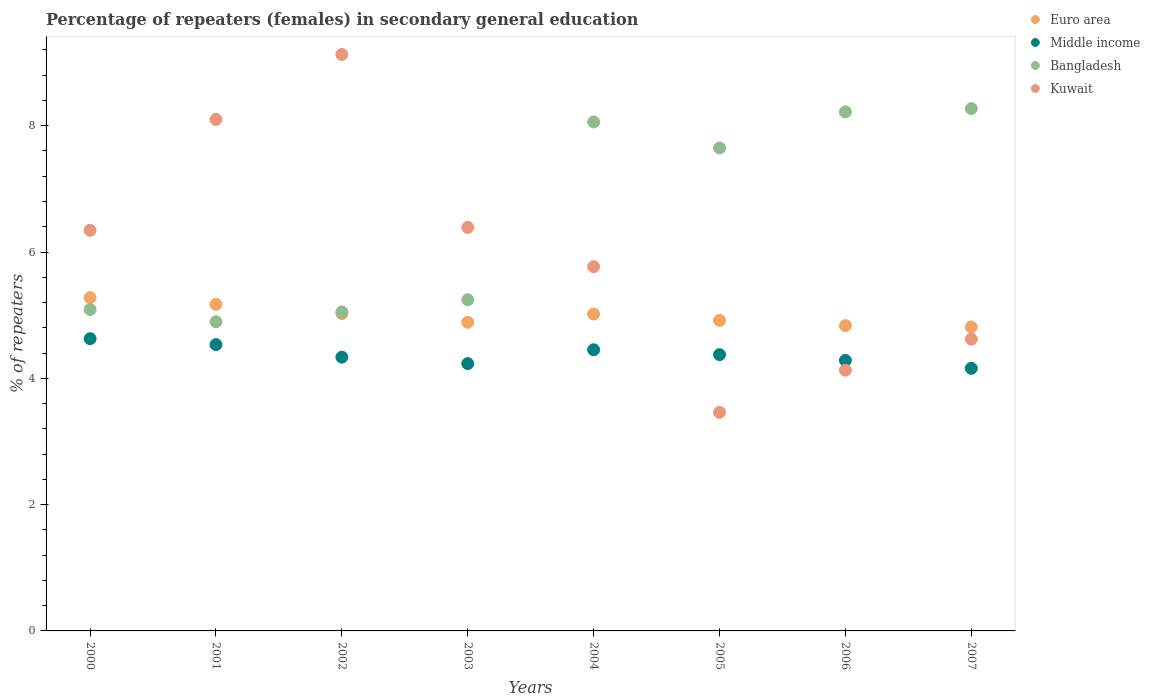What is the percentage of female repeaters in Euro area in 2002?
Give a very brief answer. 5.02. Across all years, what is the maximum percentage of female repeaters in Euro area?
Your answer should be very brief. 5.28. Across all years, what is the minimum percentage of female repeaters in Middle income?
Your answer should be compact. 4.16. In which year was the percentage of female repeaters in Kuwait maximum?
Keep it short and to the point. 2002. What is the total percentage of female repeaters in Kuwait in the graph?
Offer a terse response. 47.94. What is the difference between the percentage of female repeaters in Euro area in 2002 and that in 2007?
Provide a succinct answer. 0.21. What is the difference between the percentage of female repeaters in Kuwait in 2006 and the percentage of female repeaters in Bangladesh in 2001?
Offer a very short reply. -0.77. What is the average percentage of female repeaters in Kuwait per year?
Offer a very short reply. 5.99. In the year 2003, what is the difference between the percentage of female repeaters in Euro area and percentage of female repeaters in Kuwait?
Offer a very short reply. -1.5. What is the ratio of the percentage of female repeaters in Kuwait in 2001 to that in 2004?
Your answer should be very brief. 1.4. Is the difference between the percentage of female repeaters in Euro area in 2001 and 2003 greater than the difference between the percentage of female repeaters in Kuwait in 2001 and 2003?
Your response must be concise. No. What is the difference between the highest and the second highest percentage of female repeaters in Bangladesh?
Your response must be concise. 0.05. What is the difference between the highest and the lowest percentage of female repeaters in Bangladesh?
Offer a very short reply. 3.38. Is the sum of the percentage of female repeaters in Middle income in 2005 and 2007 greater than the maximum percentage of female repeaters in Bangladesh across all years?
Keep it short and to the point. Yes. Is it the case that in every year, the sum of the percentage of female repeaters in Euro area and percentage of female repeaters in Kuwait  is greater than the percentage of female repeaters in Middle income?
Give a very brief answer. Yes. Does the percentage of female repeaters in Kuwait monotonically increase over the years?
Keep it short and to the point. No. Is the percentage of female repeaters in Bangladesh strictly greater than the percentage of female repeaters in Kuwait over the years?
Make the answer very short. No. Is the percentage of female repeaters in Middle income strictly less than the percentage of female repeaters in Euro area over the years?
Keep it short and to the point. Yes. Are the values on the major ticks of Y-axis written in scientific E-notation?
Provide a short and direct response. No. How many legend labels are there?
Keep it short and to the point. 4. How are the legend labels stacked?
Keep it short and to the point. Vertical. What is the title of the graph?
Provide a short and direct response. Percentage of repeaters (females) in secondary general education. What is the label or title of the X-axis?
Your response must be concise. Years. What is the label or title of the Y-axis?
Ensure brevity in your answer.  % of repeaters. What is the % of repeaters in Euro area in 2000?
Make the answer very short. 5.28. What is the % of repeaters of Middle income in 2000?
Offer a terse response. 4.63. What is the % of repeaters in Bangladesh in 2000?
Offer a terse response. 5.09. What is the % of repeaters of Kuwait in 2000?
Keep it short and to the point. 6.34. What is the % of repeaters in Euro area in 2001?
Make the answer very short. 5.17. What is the % of repeaters in Middle income in 2001?
Your answer should be compact. 4.53. What is the % of repeaters in Bangladesh in 2001?
Ensure brevity in your answer.  4.9. What is the % of repeaters of Kuwait in 2001?
Your answer should be compact. 8.1. What is the % of repeaters of Euro area in 2002?
Give a very brief answer. 5.02. What is the % of repeaters in Middle income in 2002?
Keep it short and to the point. 4.34. What is the % of repeaters in Bangladesh in 2002?
Provide a succinct answer. 5.05. What is the % of repeaters of Kuwait in 2002?
Provide a short and direct response. 9.13. What is the % of repeaters of Euro area in 2003?
Your answer should be very brief. 4.89. What is the % of repeaters in Middle income in 2003?
Keep it short and to the point. 4.23. What is the % of repeaters in Bangladesh in 2003?
Your response must be concise. 5.24. What is the % of repeaters of Kuwait in 2003?
Keep it short and to the point. 6.39. What is the % of repeaters in Euro area in 2004?
Offer a very short reply. 5.02. What is the % of repeaters in Middle income in 2004?
Your answer should be very brief. 4.45. What is the % of repeaters in Bangladesh in 2004?
Your response must be concise. 8.06. What is the % of repeaters of Kuwait in 2004?
Ensure brevity in your answer.  5.77. What is the % of repeaters of Euro area in 2005?
Your answer should be compact. 4.92. What is the % of repeaters of Middle income in 2005?
Make the answer very short. 4.38. What is the % of repeaters in Bangladesh in 2005?
Your answer should be very brief. 7.65. What is the % of repeaters in Kuwait in 2005?
Provide a short and direct response. 3.46. What is the % of repeaters of Euro area in 2006?
Your answer should be compact. 4.83. What is the % of repeaters of Middle income in 2006?
Make the answer very short. 4.28. What is the % of repeaters of Bangladesh in 2006?
Offer a terse response. 8.22. What is the % of repeaters of Kuwait in 2006?
Your answer should be very brief. 4.13. What is the % of repeaters of Euro area in 2007?
Ensure brevity in your answer.  4.81. What is the % of repeaters of Middle income in 2007?
Ensure brevity in your answer.  4.16. What is the % of repeaters in Bangladesh in 2007?
Make the answer very short. 8.27. What is the % of repeaters of Kuwait in 2007?
Provide a succinct answer. 4.62. Across all years, what is the maximum % of repeaters in Euro area?
Your answer should be compact. 5.28. Across all years, what is the maximum % of repeaters in Middle income?
Make the answer very short. 4.63. Across all years, what is the maximum % of repeaters of Bangladesh?
Give a very brief answer. 8.27. Across all years, what is the maximum % of repeaters in Kuwait?
Provide a succinct answer. 9.13. Across all years, what is the minimum % of repeaters in Euro area?
Make the answer very short. 4.81. Across all years, what is the minimum % of repeaters in Middle income?
Make the answer very short. 4.16. Across all years, what is the minimum % of repeaters of Bangladesh?
Give a very brief answer. 4.9. Across all years, what is the minimum % of repeaters of Kuwait?
Ensure brevity in your answer.  3.46. What is the total % of repeaters of Euro area in the graph?
Your answer should be very brief. 39.94. What is the total % of repeaters in Middle income in the graph?
Offer a very short reply. 35. What is the total % of repeaters of Bangladesh in the graph?
Your answer should be compact. 52.48. What is the total % of repeaters in Kuwait in the graph?
Offer a terse response. 47.94. What is the difference between the % of repeaters in Euro area in 2000 and that in 2001?
Give a very brief answer. 0.11. What is the difference between the % of repeaters in Middle income in 2000 and that in 2001?
Ensure brevity in your answer.  0.09. What is the difference between the % of repeaters of Bangladesh in 2000 and that in 2001?
Give a very brief answer. 0.19. What is the difference between the % of repeaters in Kuwait in 2000 and that in 2001?
Your answer should be compact. -1.76. What is the difference between the % of repeaters of Euro area in 2000 and that in 2002?
Your answer should be very brief. 0.25. What is the difference between the % of repeaters in Middle income in 2000 and that in 2002?
Offer a very short reply. 0.29. What is the difference between the % of repeaters of Bangladesh in 2000 and that in 2002?
Your answer should be compact. 0.04. What is the difference between the % of repeaters in Kuwait in 2000 and that in 2002?
Your answer should be very brief. -2.78. What is the difference between the % of repeaters of Euro area in 2000 and that in 2003?
Ensure brevity in your answer.  0.39. What is the difference between the % of repeaters of Middle income in 2000 and that in 2003?
Your answer should be compact. 0.39. What is the difference between the % of repeaters in Bangladesh in 2000 and that in 2003?
Keep it short and to the point. -0.15. What is the difference between the % of repeaters in Kuwait in 2000 and that in 2003?
Your answer should be compact. -0.05. What is the difference between the % of repeaters of Euro area in 2000 and that in 2004?
Keep it short and to the point. 0.26. What is the difference between the % of repeaters of Middle income in 2000 and that in 2004?
Your response must be concise. 0.18. What is the difference between the % of repeaters in Bangladesh in 2000 and that in 2004?
Give a very brief answer. -2.97. What is the difference between the % of repeaters in Kuwait in 2000 and that in 2004?
Offer a terse response. 0.58. What is the difference between the % of repeaters of Euro area in 2000 and that in 2005?
Your answer should be compact. 0.36. What is the difference between the % of repeaters in Middle income in 2000 and that in 2005?
Your answer should be compact. 0.25. What is the difference between the % of repeaters of Bangladesh in 2000 and that in 2005?
Make the answer very short. -2.56. What is the difference between the % of repeaters in Kuwait in 2000 and that in 2005?
Give a very brief answer. 2.88. What is the difference between the % of repeaters in Euro area in 2000 and that in 2006?
Offer a very short reply. 0.44. What is the difference between the % of repeaters in Middle income in 2000 and that in 2006?
Your answer should be very brief. 0.34. What is the difference between the % of repeaters in Bangladesh in 2000 and that in 2006?
Give a very brief answer. -3.13. What is the difference between the % of repeaters in Kuwait in 2000 and that in 2006?
Provide a short and direct response. 2.22. What is the difference between the % of repeaters of Euro area in 2000 and that in 2007?
Offer a terse response. 0.46. What is the difference between the % of repeaters in Middle income in 2000 and that in 2007?
Provide a short and direct response. 0.47. What is the difference between the % of repeaters in Bangladesh in 2000 and that in 2007?
Make the answer very short. -3.18. What is the difference between the % of repeaters of Kuwait in 2000 and that in 2007?
Ensure brevity in your answer.  1.72. What is the difference between the % of repeaters in Euro area in 2001 and that in 2002?
Provide a succinct answer. 0.15. What is the difference between the % of repeaters in Middle income in 2001 and that in 2002?
Your response must be concise. 0.2. What is the difference between the % of repeaters of Bangladesh in 2001 and that in 2002?
Your answer should be compact. -0.16. What is the difference between the % of repeaters in Kuwait in 2001 and that in 2002?
Your answer should be compact. -1.03. What is the difference between the % of repeaters in Euro area in 2001 and that in 2003?
Ensure brevity in your answer.  0.28. What is the difference between the % of repeaters in Middle income in 2001 and that in 2003?
Keep it short and to the point. 0.3. What is the difference between the % of repeaters in Bangladesh in 2001 and that in 2003?
Make the answer very short. -0.35. What is the difference between the % of repeaters in Kuwait in 2001 and that in 2003?
Provide a short and direct response. 1.71. What is the difference between the % of repeaters of Euro area in 2001 and that in 2004?
Offer a terse response. 0.15. What is the difference between the % of repeaters of Middle income in 2001 and that in 2004?
Your response must be concise. 0.08. What is the difference between the % of repeaters in Bangladesh in 2001 and that in 2004?
Keep it short and to the point. -3.16. What is the difference between the % of repeaters of Kuwait in 2001 and that in 2004?
Give a very brief answer. 2.33. What is the difference between the % of repeaters of Euro area in 2001 and that in 2005?
Provide a short and direct response. 0.26. What is the difference between the % of repeaters of Middle income in 2001 and that in 2005?
Provide a succinct answer. 0.16. What is the difference between the % of repeaters in Bangladesh in 2001 and that in 2005?
Your answer should be compact. -2.75. What is the difference between the % of repeaters in Kuwait in 2001 and that in 2005?
Provide a succinct answer. 4.64. What is the difference between the % of repeaters in Euro area in 2001 and that in 2006?
Ensure brevity in your answer.  0.34. What is the difference between the % of repeaters of Middle income in 2001 and that in 2006?
Keep it short and to the point. 0.25. What is the difference between the % of repeaters of Bangladesh in 2001 and that in 2006?
Make the answer very short. -3.32. What is the difference between the % of repeaters in Kuwait in 2001 and that in 2006?
Provide a short and direct response. 3.97. What is the difference between the % of repeaters in Euro area in 2001 and that in 2007?
Your answer should be compact. 0.36. What is the difference between the % of repeaters in Middle income in 2001 and that in 2007?
Offer a very short reply. 0.38. What is the difference between the % of repeaters in Bangladesh in 2001 and that in 2007?
Offer a very short reply. -3.38. What is the difference between the % of repeaters of Kuwait in 2001 and that in 2007?
Offer a very short reply. 3.48. What is the difference between the % of repeaters of Euro area in 2002 and that in 2003?
Your answer should be very brief. 0.14. What is the difference between the % of repeaters in Middle income in 2002 and that in 2003?
Ensure brevity in your answer.  0.1. What is the difference between the % of repeaters in Bangladesh in 2002 and that in 2003?
Your answer should be very brief. -0.19. What is the difference between the % of repeaters in Kuwait in 2002 and that in 2003?
Give a very brief answer. 2.74. What is the difference between the % of repeaters in Euro area in 2002 and that in 2004?
Ensure brevity in your answer.  0.01. What is the difference between the % of repeaters of Middle income in 2002 and that in 2004?
Offer a terse response. -0.12. What is the difference between the % of repeaters of Bangladesh in 2002 and that in 2004?
Make the answer very short. -3.01. What is the difference between the % of repeaters of Kuwait in 2002 and that in 2004?
Your answer should be very brief. 3.36. What is the difference between the % of repeaters of Euro area in 2002 and that in 2005?
Your answer should be compact. 0.11. What is the difference between the % of repeaters in Middle income in 2002 and that in 2005?
Keep it short and to the point. -0.04. What is the difference between the % of repeaters of Bangladesh in 2002 and that in 2005?
Your response must be concise. -2.6. What is the difference between the % of repeaters in Kuwait in 2002 and that in 2005?
Provide a succinct answer. 5.67. What is the difference between the % of repeaters of Euro area in 2002 and that in 2006?
Offer a terse response. 0.19. What is the difference between the % of repeaters of Middle income in 2002 and that in 2006?
Ensure brevity in your answer.  0.05. What is the difference between the % of repeaters in Bangladesh in 2002 and that in 2006?
Your response must be concise. -3.17. What is the difference between the % of repeaters in Kuwait in 2002 and that in 2006?
Offer a terse response. 5. What is the difference between the % of repeaters in Euro area in 2002 and that in 2007?
Give a very brief answer. 0.21. What is the difference between the % of repeaters in Middle income in 2002 and that in 2007?
Offer a very short reply. 0.18. What is the difference between the % of repeaters in Bangladesh in 2002 and that in 2007?
Ensure brevity in your answer.  -3.22. What is the difference between the % of repeaters in Kuwait in 2002 and that in 2007?
Ensure brevity in your answer.  4.51. What is the difference between the % of repeaters in Euro area in 2003 and that in 2004?
Give a very brief answer. -0.13. What is the difference between the % of repeaters of Middle income in 2003 and that in 2004?
Provide a succinct answer. -0.22. What is the difference between the % of repeaters of Bangladesh in 2003 and that in 2004?
Your answer should be compact. -2.82. What is the difference between the % of repeaters in Kuwait in 2003 and that in 2004?
Your answer should be compact. 0.62. What is the difference between the % of repeaters in Euro area in 2003 and that in 2005?
Offer a terse response. -0.03. What is the difference between the % of repeaters in Middle income in 2003 and that in 2005?
Make the answer very short. -0.14. What is the difference between the % of repeaters in Bangladesh in 2003 and that in 2005?
Ensure brevity in your answer.  -2.4. What is the difference between the % of repeaters in Kuwait in 2003 and that in 2005?
Provide a succinct answer. 2.93. What is the difference between the % of repeaters in Euro area in 2003 and that in 2006?
Give a very brief answer. 0.05. What is the difference between the % of repeaters of Middle income in 2003 and that in 2006?
Your answer should be compact. -0.05. What is the difference between the % of repeaters in Bangladesh in 2003 and that in 2006?
Make the answer very short. -2.98. What is the difference between the % of repeaters in Kuwait in 2003 and that in 2006?
Your answer should be compact. 2.26. What is the difference between the % of repeaters of Euro area in 2003 and that in 2007?
Provide a succinct answer. 0.07. What is the difference between the % of repeaters of Middle income in 2003 and that in 2007?
Offer a terse response. 0.08. What is the difference between the % of repeaters in Bangladesh in 2003 and that in 2007?
Provide a succinct answer. -3.03. What is the difference between the % of repeaters of Kuwait in 2003 and that in 2007?
Your answer should be compact. 1.77. What is the difference between the % of repeaters of Euro area in 2004 and that in 2005?
Ensure brevity in your answer.  0.1. What is the difference between the % of repeaters in Middle income in 2004 and that in 2005?
Make the answer very short. 0.08. What is the difference between the % of repeaters of Bangladesh in 2004 and that in 2005?
Ensure brevity in your answer.  0.41. What is the difference between the % of repeaters in Kuwait in 2004 and that in 2005?
Provide a short and direct response. 2.31. What is the difference between the % of repeaters in Euro area in 2004 and that in 2006?
Make the answer very short. 0.18. What is the difference between the % of repeaters in Middle income in 2004 and that in 2006?
Your response must be concise. 0.17. What is the difference between the % of repeaters in Bangladesh in 2004 and that in 2006?
Provide a succinct answer. -0.16. What is the difference between the % of repeaters in Kuwait in 2004 and that in 2006?
Keep it short and to the point. 1.64. What is the difference between the % of repeaters of Euro area in 2004 and that in 2007?
Your response must be concise. 0.2. What is the difference between the % of repeaters in Middle income in 2004 and that in 2007?
Offer a terse response. 0.29. What is the difference between the % of repeaters of Bangladesh in 2004 and that in 2007?
Your answer should be compact. -0.21. What is the difference between the % of repeaters of Kuwait in 2004 and that in 2007?
Offer a very short reply. 1.15. What is the difference between the % of repeaters in Euro area in 2005 and that in 2006?
Keep it short and to the point. 0.08. What is the difference between the % of repeaters in Middle income in 2005 and that in 2006?
Your response must be concise. 0.09. What is the difference between the % of repeaters in Bangladesh in 2005 and that in 2006?
Keep it short and to the point. -0.57. What is the difference between the % of repeaters of Kuwait in 2005 and that in 2006?
Provide a succinct answer. -0.67. What is the difference between the % of repeaters in Euro area in 2005 and that in 2007?
Offer a very short reply. 0.1. What is the difference between the % of repeaters of Middle income in 2005 and that in 2007?
Keep it short and to the point. 0.22. What is the difference between the % of repeaters in Bangladesh in 2005 and that in 2007?
Your answer should be very brief. -0.62. What is the difference between the % of repeaters in Kuwait in 2005 and that in 2007?
Your response must be concise. -1.16. What is the difference between the % of repeaters in Euro area in 2006 and that in 2007?
Offer a terse response. 0.02. What is the difference between the % of repeaters in Middle income in 2006 and that in 2007?
Provide a short and direct response. 0.13. What is the difference between the % of repeaters of Bangladesh in 2006 and that in 2007?
Ensure brevity in your answer.  -0.05. What is the difference between the % of repeaters in Kuwait in 2006 and that in 2007?
Keep it short and to the point. -0.49. What is the difference between the % of repeaters of Euro area in 2000 and the % of repeaters of Middle income in 2001?
Your answer should be very brief. 0.74. What is the difference between the % of repeaters in Euro area in 2000 and the % of repeaters in Bangladesh in 2001?
Provide a succinct answer. 0.38. What is the difference between the % of repeaters of Euro area in 2000 and the % of repeaters of Kuwait in 2001?
Provide a succinct answer. -2.82. What is the difference between the % of repeaters in Middle income in 2000 and the % of repeaters in Bangladesh in 2001?
Offer a terse response. -0.27. What is the difference between the % of repeaters in Middle income in 2000 and the % of repeaters in Kuwait in 2001?
Provide a succinct answer. -3.47. What is the difference between the % of repeaters of Bangladesh in 2000 and the % of repeaters of Kuwait in 2001?
Offer a very short reply. -3.01. What is the difference between the % of repeaters of Euro area in 2000 and the % of repeaters of Middle income in 2002?
Offer a terse response. 0.94. What is the difference between the % of repeaters of Euro area in 2000 and the % of repeaters of Bangladesh in 2002?
Offer a very short reply. 0.23. What is the difference between the % of repeaters in Euro area in 2000 and the % of repeaters in Kuwait in 2002?
Your answer should be compact. -3.85. What is the difference between the % of repeaters of Middle income in 2000 and the % of repeaters of Bangladesh in 2002?
Offer a terse response. -0.42. What is the difference between the % of repeaters in Middle income in 2000 and the % of repeaters in Kuwait in 2002?
Give a very brief answer. -4.5. What is the difference between the % of repeaters of Bangladesh in 2000 and the % of repeaters of Kuwait in 2002?
Provide a succinct answer. -4.04. What is the difference between the % of repeaters of Euro area in 2000 and the % of repeaters of Middle income in 2003?
Make the answer very short. 1.04. What is the difference between the % of repeaters in Euro area in 2000 and the % of repeaters in Bangladesh in 2003?
Give a very brief answer. 0.03. What is the difference between the % of repeaters of Euro area in 2000 and the % of repeaters of Kuwait in 2003?
Your response must be concise. -1.11. What is the difference between the % of repeaters in Middle income in 2000 and the % of repeaters in Bangladesh in 2003?
Offer a very short reply. -0.62. What is the difference between the % of repeaters in Middle income in 2000 and the % of repeaters in Kuwait in 2003?
Your answer should be compact. -1.76. What is the difference between the % of repeaters of Bangladesh in 2000 and the % of repeaters of Kuwait in 2003?
Offer a very short reply. -1.3. What is the difference between the % of repeaters in Euro area in 2000 and the % of repeaters in Middle income in 2004?
Keep it short and to the point. 0.82. What is the difference between the % of repeaters of Euro area in 2000 and the % of repeaters of Bangladesh in 2004?
Make the answer very short. -2.78. What is the difference between the % of repeaters in Euro area in 2000 and the % of repeaters in Kuwait in 2004?
Your response must be concise. -0.49. What is the difference between the % of repeaters in Middle income in 2000 and the % of repeaters in Bangladesh in 2004?
Your answer should be very brief. -3.43. What is the difference between the % of repeaters in Middle income in 2000 and the % of repeaters in Kuwait in 2004?
Your answer should be very brief. -1.14. What is the difference between the % of repeaters in Bangladesh in 2000 and the % of repeaters in Kuwait in 2004?
Your answer should be very brief. -0.68. What is the difference between the % of repeaters in Euro area in 2000 and the % of repeaters in Middle income in 2005?
Your answer should be compact. 0.9. What is the difference between the % of repeaters of Euro area in 2000 and the % of repeaters of Bangladesh in 2005?
Provide a succinct answer. -2.37. What is the difference between the % of repeaters of Euro area in 2000 and the % of repeaters of Kuwait in 2005?
Make the answer very short. 1.82. What is the difference between the % of repeaters of Middle income in 2000 and the % of repeaters of Bangladesh in 2005?
Provide a succinct answer. -3.02. What is the difference between the % of repeaters in Middle income in 2000 and the % of repeaters in Kuwait in 2005?
Give a very brief answer. 1.17. What is the difference between the % of repeaters in Bangladesh in 2000 and the % of repeaters in Kuwait in 2005?
Provide a succinct answer. 1.63. What is the difference between the % of repeaters of Euro area in 2000 and the % of repeaters of Bangladesh in 2006?
Your answer should be very brief. -2.94. What is the difference between the % of repeaters in Euro area in 2000 and the % of repeaters in Kuwait in 2006?
Your response must be concise. 1.15. What is the difference between the % of repeaters of Middle income in 2000 and the % of repeaters of Bangladesh in 2006?
Offer a very short reply. -3.59. What is the difference between the % of repeaters in Middle income in 2000 and the % of repeaters in Kuwait in 2006?
Ensure brevity in your answer.  0.5. What is the difference between the % of repeaters of Bangladesh in 2000 and the % of repeaters of Kuwait in 2006?
Keep it short and to the point. 0.96. What is the difference between the % of repeaters of Euro area in 2000 and the % of repeaters of Middle income in 2007?
Your answer should be compact. 1.12. What is the difference between the % of repeaters in Euro area in 2000 and the % of repeaters in Bangladesh in 2007?
Provide a succinct answer. -2.99. What is the difference between the % of repeaters of Euro area in 2000 and the % of repeaters of Kuwait in 2007?
Offer a terse response. 0.66. What is the difference between the % of repeaters in Middle income in 2000 and the % of repeaters in Bangladesh in 2007?
Your answer should be very brief. -3.64. What is the difference between the % of repeaters of Middle income in 2000 and the % of repeaters of Kuwait in 2007?
Your answer should be compact. 0.01. What is the difference between the % of repeaters in Bangladesh in 2000 and the % of repeaters in Kuwait in 2007?
Provide a succinct answer. 0.47. What is the difference between the % of repeaters in Euro area in 2001 and the % of repeaters in Middle income in 2002?
Make the answer very short. 0.84. What is the difference between the % of repeaters of Euro area in 2001 and the % of repeaters of Bangladesh in 2002?
Make the answer very short. 0.12. What is the difference between the % of repeaters of Euro area in 2001 and the % of repeaters of Kuwait in 2002?
Your answer should be very brief. -3.96. What is the difference between the % of repeaters in Middle income in 2001 and the % of repeaters in Bangladesh in 2002?
Keep it short and to the point. -0.52. What is the difference between the % of repeaters of Middle income in 2001 and the % of repeaters of Kuwait in 2002?
Ensure brevity in your answer.  -4.59. What is the difference between the % of repeaters of Bangladesh in 2001 and the % of repeaters of Kuwait in 2002?
Provide a succinct answer. -4.23. What is the difference between the % of repeaters of Euro area in 2001 and the % of repeaters of Middle income in 2003?
Offer a terse response. 0.94. What is the difference between the % of repeaters of Euro area in 2001 and the % of repeaters of Bangladesh in 2003?
Your answer should be very brief. -0.07. What is the difference between the % of repeaters in Euro area in 2001 and the % of repeaters in Kuwait in 2003?
Your answer should be very brief. -1.22. What is the difference between the % of repeaters in Middle income in 2001 and the % of repeaters in Bangladesh in 2003?
Offer a terse response. -0.71. What is the difference between the % of repeaters in Middle income in 2001 and the % of repeaters in Kuwait in 2003?
Offer a very short reply. -1.86. What is the difference between the % of repeaters of Bangladesh in 2001 and the % of repeaters of Kuwait in 2003?
Give a very brief answer. -1.49. What is the difference between the % of repeaters of Euro area in 2001 and the % of repeaters of Middle income in 2004?
Make the answer very short. 0.72. What is the difference between the % of repeaters of Euro area in 2001 and the % of repeaters of Bangladesh in 2004?
Your response must be concise. -2.89. What is the difference between the % of repeaters of Euro area in 2001 and the % of repeaters of Kuwait in 2004?
Ensure brevity in your answer.  -0.6. What is the difference between the % of repeaters in Middle income in 2001 and the % of repeaters in Bangladesh in 2004?
Your response must be concise. -3.53. What is the difference between the % of repeaters in Middle income in 2001 and the % of repeaters in Kuwait in 2004?
Offer a terse response. -1.23. What is the difference between the % of repeaters in Bangladesh in 2001 and the % of repeaters in Kuwait in 2004?
Keep it short and to the point. -0.87. What is the difference between the % of repeaters in Euro area in 2001 and the % of repeaters in Middle income in 2005?
Make the answer very short. 0.8. What is the difference between the % of repeaters in Euro area in 2001 and the % of repeaters in Bangladesh in 2005?
Provide a succinct answer. -2.48. What is the difference between the % of repeaters in Euro area in 2001 and the % of repeaters in Kuwait in 2005?
Your answer should be compact. 1.71. What is the difference between the % of repeaters of Middle income in 2001 and the % of repeaters of Bangladesh in 2005?
Provide a succinct answer. -3.11. What is the difference between the % of repeaters of Middle income in 2001 and the % of repeaters of Kuwait in 2005?
Your response must be concise. 1.07. What is the difference between the % of repeaters of Bangladesh in 2001 and the % of repeaters of Kuwait in 2005?
Ensure brevity in your answer.  1.43. What is the difference between the % of repeaters of Euro area in 2001 and the % of repeaters of Middle income in 2006?
Make the answer very short. 0.89. What is the difference between the % of repeaters in Euro area in 2001 and the % of repeaters in Bangladesh in 2006?
Your answer should be compact. -3.05. What is the difference between the % of repeaters in Euro area in 2001 and the % of repeaters in Kuwait in 2006?
Make the answer very short. 1.04. What is the difference between the % of repeaters of Middle income in 2001 and the % of repeaters of Bangladesh in 2006?
Ensure brevity in your answer.  -3.69. What is the difference between the % of repeaters of Middle income in 2001 and the % of repeaters of Kuwait in 2006?
Provide a succinct answer. 0.4. What is the difference between the % of repeaters of Bangladesh in 2001 and the % of repeaters of Kuwait in 2006?
Offer a terse response. 0.77. What is the difference between the % of repeaters in Euro area in 2001 and the % of repeaters in Middle income in 2007?
Your answer should be very brief. 1.01. What is the difference between the % of repeaters in Euro area in 2001 and the % of repeaters in Bangladesh in 2007?
Ensure brevity in your answer.  -3.1. What is the difference between the % of repeaters of Euro area in 2001 and the % of repeaters of Kuwait in 2007?
Your answer should be very brief. 0.55. What is the difference between the % of repeaters of Middle income in 2001 and the % of repeaters of Bangladesh in 2007?
Give a very brief answer. -3.74. What is the difference between the % of repeaters of Middle income in 2001 and the % of repeaters of Kuwait in 2007?
Your answer should be very brief. -0.09. What is the difference between the % of repeaters of Bangladesh in 2001 and the % of repeaters of Kuwait in 2007?
Provide a short and direct response. 0.28. What is the difference between the % of repeaters of Euro area in 2002 and the % of repeaters of Middle income in 2003?
Your answer should be compact. 0.79. What is the difference between the % of repeaters in Euro area in 2002 and the % of repeaters in Bangladesh in 2003?
Your answer should be compact. -0.22. What is the difference between the % of repeaters in Euro area in 2002 and the % of repeaters in Kuwait in 2003?
Keep it short and to the point. -1.37. What is the difference between the % of repeaters in Middle income in 2002 and the % of repeaters in Bangladesh in 2003?
Offer a terse response. -0.91. What is the difference between the % of repeaters of Middle income in 2002 and the % of repeaters of Kuwait in 2003?
Your answer should be very brief. -2.05. What is the difference between the % of repeaters in Bangladesh in 2002 and the % of repeaters in Kuwait in 2003?
Give a very brief answer. -1.34. What is the difference between the % of repeaters in Euro area in 2002 and the % of repeaters in Middle income in 2004?
Your answer should be very brief. 0.57. What is the difference between the % of repeaters in Euro area in 2002 and the % of repeaters in Bangladesh in 2004?
Your answer should be very brief. -3.04. What is the difference between the % of repeaters in Euro area in 2002 and the % of repeaters in Kuwait in 2004?
Offer a very short reply. -0.74. What is the difference between the % of repeaters in Middle income in 2002 and the % of repeaters in Bangladesh in 2004?
Keep it short and to the point. -3.73. What is the difference between the % of repeaters of Middle income in 2002 and the % of repeaters of Kuwait in 2004?
Offer a terse response. -1.43. What is the difference between the % of repeaters in Bangladesh in 2002 and the % of repeaters in Kuwait in 2004?
Offer a very short reply. -0.72. What is the difference between the % of repeaters in Euro area in 2002 and the % of repeaters in Middle income in 2005?
Provide a succinct answer. 0.65. What is the difference between the % of repeaters of Euro area in 2002 and the % of repeaters of Bangladesh in 2005?
Make the answer very short. -2.62. What is the difference between the % of repeaters in Euro area in 2002 and the % of repeaters in Kuwait in 2005?
Your answer should be compact. 1.56. What is the difference between the % of repeaters of Middle income in 2002 and the % of repeaters of Bangladesh in 2005?
Your answer should be compact. -3.31. What is the difference between the % of repeaters of Middle income in 2002 and the % of repeaters of Kuwait in 2005?
Offer a very short reply. 0.87. What is the difference between the % of repeaters in Bangladesh in 2002 and the % of repeaters in Kuwait in 2005?
Your answer should be very brief. 1.59. What is the difference between the % of repeaters in Euro area in 2002 and the % of repeaters in Middle income in 2006?
Provide a short and direct response. 0.74. What is the difference between the % of repeaters of Euro area in 2002 and the % of repeaters of Bangladesh in 2006?
Offer a terse response. -3.2. What is the difference between the % of repeaters in Euro area in 2002 and the % of repeaters in Kuwait in 2006?
Your answer should be very brief. 0.89. What is the difference between the % of repeaters in Middle income in 2002 and the % of repeaters in Bangladesh in 2006?
Keep it short and to the point. -3.88. What is the difference between the % of repeaters in Middle income in 2002 and the % of repeaters in Kuwait in 2006?
Ensure brevity in your answer.  0.21. What is the difference between the % of repeaters of Bangladesh in 2002 and the % of repeaters of Kuwait in 2006?
Make the answer very short. 0.92. What is the difference between the % of repeaters in Euro area in 2002 and the % of repeaters in Middle income in 2007?
Your response must be concise. 0.87. What is the difference between the % of repeaters of Euro area in 2002 and the % of repeaters of Bangladesh in 2007?
Offer a very short reply. -3.25. What is the difference between the % of repeaters in Euro area in 2002 and the % of repeaters in Kuwait in 2007?
Offer a terse response. 0.4. What is the difference between the % of repeaters of Middle income in 2002 and the % of repeaters of Bangladesh in 2007?
Provide a succinct answer. -3.94. What is the difference between the % of repeaters in Middle income in 2002 and the % of repeaters in Kuwait in 2007?
Offer a very short reply. -0.29. What is the difference between the % of repeaters in Bangladesh in 2002 and the % of repeaters in Kuwait in 2007?
Make the answer very short. 0.43. What is the difference between the % of repeaters in Euro area in 2003 and the % of repeaters in Middle income in 2004?
Offer a terse response. 0.43. What is the difference between the % of repeaters of Euro area in 2003 and the % of repeaters of Bangladesh in 2004?
Keep it short and to the point. -3.17. What is the difference between the % of repeaters in Euro area in 2003 and the % of repeaters in Kuwait in 2004?
Make the answer very short. -0.88. What is the difference between the % of repeaters in Middle income in 2003 and the % of repeaters in Bangladesh in 2004?
Ensure brevity in your answer.  -3.83. What is the difference between the % of repeaters in Middle income in 2003 and the % of repeaters in Kuwait in 2004?
Provide a succinct answer. -1.53. What is the difference between the % of repeaters in Bangladesh in 2003 and the % of repeaters in Kuwait in 2004?
Provide a short and direct response. -0.52. What is the difference between the % of repeaters of Euro area in 2003 and the % of repeaters of Middle income in 2005?
Make the answer very short. 0.51. What is the difference between the % of repeaters of Euro area in 2003 and the % of repeaters of Bangladesh in 2005?
Provide a succinct answer. -2.76. What is the difference between the % of repeaters in Euro area in 2003 and the % of repeaters in Kuwait in 2005?
Provide a succinct answer. 1.43. What is the difference between the % of repeaters of Middle income in 2003 and the % of repeaters of Bangladesh in 2005?
Offer a very short reply. -3.41. What is the difference between the % of repeaters of Middle income in 2003 and the % of repeaters of Kuwait in 2005?
Give a very brief answer. 0.77. What is the difference between the % of repeaters of Bangladesh in 2003 and the % of repeaters of Kuwait in 2005?
Ensure brevity in your answer.  1.78. What is the difference between the % of repeaters in Euro area in 2003 and the % of repeaters in Middle income in 2006?
Your answer should be very brief. 0.6. What is the difference between the % of repeaters of Euro area in 2003 and the % of repeaters of Bangladesh in 2006?
Provide a succinct answer. -3.33. What is the difference between the % of repeaters in Euro area in 2003 and the % of repeaters in Kuwait in 2006?
Your answer should be compact. 0.76. What is the difference between the % of repeaters in Middle income in 2003 and the % of repeaters in Bangladesh in 2006?
Ensure brevity in your answer.  -3.99. What is the difference between the % of repeaters of Middle income in 2003 and the % of repeaters of Kuwait in 2006?
Keep it short and to the point. 0.1. What is the difference between the % of repeaters of Bangladesh in 2003 and the % of repeaters of Kuwait in 2006?
Provide a succinct answer. 1.12. What is the difference between the % of repeaters of Euro area in 2003 and the % of repeaters of Middle income in 2007?
Offer a terse response. 0.73. What is the difference between the % of repeaters of Euro area in 2003 and the % of repeaters of Bangladesh in 2007?
Provide a succinct answer. -3.38. What is the difference between the % of repeaters in Euro area in 2003 and the % of repeaters in Kuwait in 2007?
Provide a short and direct response. 0.27. What is the difference between the % of repeaters of Middle income in 2003 and the % of repeaters of Bangladesh in 2007?
Make the answer very short. -4.04. What is the difference between the % of repeaters of Middle income in 2003 and the % of repeaters of Kuwait in 2007?
Your answer should be very brief. -0.39. What is the difference between the % of repeaters in Bangladesh in 2003 and the % of repeaters in Kuwait in 2007?
Your response must be concise. 0.62. What is the difference between the % of repeaters of Euro area in 2004 and the % of repeaters of Middle income in 2005?
Give a very brief answer. 0.64. What is the difference between the % of repeaters of Euro area in 2004 and the % of repeaters of Bangladesh in 2005?
Offer a terse response. -2.63. What is the difference between the % of repeaters of Euro area in 2004 and the % of repeaters of Kuwait in 2005?
Keep it short and to the point. 1.56. What is the difference between the % of repeaters of Middle income in 2004 and the % of repeaters of Bangladesh in 2005?
Ensure brevity in your answer.  -3.2. What is the difference between the % of repeaters in Bangladesh in 2004 and the % of repeaters in Kuwait in 2005?
Make the answer very short. 4.6. What is the difference between the % of repeaters of Euro area in 2004 and the % of repeaters of Middle income in 2006?
Provide a succinct answer. 0.73. What is the difference between the % of repeaters in Euro area in 2004 and the % of repeaters in Bangladesh in 2006?
Provide a succinct answer. -3.2. What is the difference between the % of repeaters in Euro area in 2004 and the % of repeaters in Kuwait in 2006?
Offer a terse response. 0.89. What is the difference between the % of repeaters in Middle income in 2004 and the % of repeaters in Bangladesh in 2006?
Your answer should be very brief. -3.77. What is the difference between the % of repeaters in Middle income in 2004 and the % of repeaters in Kuwait in 2006?
Your answer should be very brief. 0.32. What is the difference between the % of repeaters of Bangladesh in 2004 and the % of repeaters of Kuwait in 2006?
Your answer should be compact. 3.93. What is the difference between the % of repeaters in Euro area in 2004 and the % of repeaters in Middle income in 2007?
Your response must be concise. 0.86. What is the difference between the % of repeaters in Euro area in 2004 and the % of repeaters in Bangladesh in 2007?
Your answer should be very brief. -3.25. What is the difference between the % of repeaters of Euro area in 2004 and the % of repeaters of Kuwait in 2007?
Offer a terse response. 0.4. What is the difference between the % of repeaters in Middle income in 2004 and the % of repeaters in Bangladesh in 2007?
Make the answer very short. -3.82. What is the difference between the % of repeaters in Middle income in 2004 and the % of repeaters in Kuwait in 2007?
Offer a very short reply. -0.17. What is the difference between the % of repeaters of Bangladesh in 2004 and the % of repeaters of Kuwait in 2007?
Make the answer very short. 3.44. What is the difference between the % of repeaters of Euro area in 2005 and the % of repeaters of Middle income in 2006?
Offer a terse response. 0.63. What is the difference between the % of repeaters of Euro area in 2005 and the % of repeaters of Bangladesh in 2006?
Ensure brevity in your answer.  -3.3. What is the difference between the % of repeaters in Euro area in 2005 and the % of repeaters in Kuwait in 2006?
Keep it short and to the point. 0.79. What is the difference between the % of repeaters of Middle income in 2005 and the % of repeaters of Bangladesh in 2006?
Ensure brevity in your answer.  -3.84. What is the difference between the % of repeaters of Middle income in 2005 and the % of repeaters of Kuwait in 2006?
Ensure brevity in your answer.  0.25. What is the difference between the % of repeaters in Bangladesh in 2005 and the % of repeaters in Kuwait in 2006?
Ensure brevity in your answer.  3.52. What is the difference between the % of repeaters of Euro area in 2005 and the % of repeaters of Middle income in 2007?
Provide a succinct answer. 0.76. What is the difference between the % of repeaters of Euro area in 2005 and the % of repeaters of Bangladesh in 2007?
Provide a short and direct response. -3.36. What is the difference between the % of repeaters of Euro area in 2005 and the % of repeaters of Kuwait in 2007?
Your response must be concise. 0.3. What is the difference between the % of repeaters of Middle income in 2005 and the % of repeaters of Bangladesh in 2007?
Your answer should be very brief. -3.9. What is the difference between the % of repeaters of Middle income in 2005 and the % of repeaters of Kuwait in 2007?
Your answer should be compact. -0.24. What is the difference between the % of repeaters in Bangladesh in 2005 and the % of repeaters in Kuwait in 2007?
Offer a terse response. 3.03. What is the difference between the % of repeaters of Euro area in 2006 and the % of repeaters of Middle income in 2007?
Your answer should be very brief. 0.68. What is the difference between the % of repeaters of Euro area in 2006 and the % of repeaters of Bangladesh in 2007?
Offer a very short reply. -3.44. What is the difference between the % of repeaters in Euro area in 2006 and the % of repeaters in Kuwait in 2007?
Make the answer very short. 0.21. What is the difference between the % of repeaters of Middle income in 2006 and the % of repeaters of Bangladesh in 2007?
Keep it short and to the point. -3.99. What is the difference between the % of repeaters in Middle income in 2006 and the % of repeaters in Kuwait in 2007?
Make the answer very short. -0.34. What is the difference between the % of repeaters in Bangladesh in 2006 and the % of repeaters in Kuwait in 2007?
Give a very brief answer. 3.6. What is the average % of repeaters in Euro area per year?
Your answer should be compact. 4.99. What is the average % of repeaters in Middle income per year?
Offer a very short reply. 4.38. What is the average % of repeaters in Bangladesh per year?
Give a very brief answer. 6.56. What is the average % of repeaters in Kuwait per year?
Offer a very short reply. 5.99. In the year 2000, what is the difference between the % of repeaters of Euro area and % of repeaters of Middle income?
Your response must be concise. 0.65. In the year 2000, what is the difference between the % of repeaters in Euro area and % of repeaters in Bangladesh?
Provide a short and direct response. 0.19. In the year 2000, what is the difference between the % of repeaters in Euro area and % of repeaters in Kuwait?
Offer a terse response. -1.07. In the year 2000, what is the difference between the % of repeaters of Middle income and % of repeaters of Bangladesh?
Offer a very short reply. -0.46. In the year 2000, what is the difference between the % of repeaters of Middle income and % of repeaters of Kuwait?
Ensure brevity in your answer.  -1.72. In the year 2000, what is the difference between the % of repeaters of Bangladesh and % of repeaters of Kuwait?
Your response must be concise. -1.25. In the year 2001, what is the difference between the % of repeaters of Euro area and % of repeaters of Middle income?
Provide a succinct answer. 0.64. In the year 2001, what is the difference between the % of repeaters of Euro area and % of repeaters of Bangladesh?
Your response must be concise. 0.28. In the year 2001, what is the difference between the % of repeaters in Euro area and % of repeaters in Kuwait?
Your response must be concise. -2.93. In the year 2001, what is the difference between the % of repeaters of Middle income and % of repeaters of Bangladesh?
Provide a short and direct response. -0.36. In the year 2001, what is the difference between the % of repeaters in Middle income and % of repeaters in Kuwait?
Provide a short and direct response. -3.57. In the year 2001, what is the difference between the % of repeaters of Bangladesh and % of repeaters of Kuwait?
Ensure brevity in your answer.  -3.2. In the year 2002, what is the difference between the % of repeaters in Euro area and % of repeaters in Middle income?
Give a very brief answer. 0.69. In the year 2002, what is the difference between the % of repeaters of Euro area and % of repeaters of Bangladesh?
Your answer should be very brief. -0.03. In the year 2002, what is the difference between the % of repeaters in Euro area and % of repeaters in Kuwait?
Ensure brevity in your answer.  -4.1. In the year 2002, what is the difference between the % of repeaters in Middle income and % of repeaters in Bangladesh?
Your answer should be compact. -0.72. In the year 2002, what is the difference between the % of repeaters of Middle income and % of repeaters of Kuwait?
Make the answer very short. -4.79. In the year 2002, what is the difference between the % of repeaters in Bangladesh and % of repeaters in Kuwait?
Provide a short and direct response. -4.08. In the year 2003, what is the difference between the % of repeaters of Euro area and % of repeaters of Middle income?
Offer a very short reply. 0.65. In the year 2003, what is the difference between the % of repeaters in Euro area and % of repeaters in Bangladesh?
Offer a very short reply. -0.36. In the year 2003, what is the difference between the % of repeaters in Euro area and % of repeaters in Kuwait?
Your response must be concise. -1.5. In the year 2003, what is the difference between the % of repeaters of Middle income and % of repeaters of Bangladesh?
Provide a succinct answer. -1.01. In the year 2003, what is the difference between the % of repeaters in Middle income and % of repeaters in Kuwait?
Offer a terse response. -2.16. In the year 2003, what is the difference between the % of repeaters in Bangladesh and % of repeaters in Kuwait?
Offer a terse response. -1.15. In the year 2004, what is the difference between the % of repeaters of Euro area and % of repeaters of Middle income?
Offer a very short reply. 0.57. In the year 2004, what is the difference between the % of repeaters of Euro area and % of repeaters of Bangladesh?
Your answer should be compact. -3.04. In the year 2004, what is the difference between the % of repeaters of Euro area and % of repeaters of Kuwait?
Ensure brevity in your answer.  -0.75. In the year 2004, what is the difference between the % of repeaters in Middle income and % of repeaters in Bangladesh?
Your answer should be very brief. -3.61. In the year 2004, what is the difference between the % of repeaters in Middle income and % of repeaters in Kuwait?
Provide a short and direct response. -1.32. In the year 2004, what is the difference between the % of repeaters in Bangladesh and % of repeaters in Kuwait?
Offer a terse response. 2.29. In the year 2005, what is the difference between the % of repeaters of Euro area and % of repeaters of Middle income?
Offer a very short reply. 0.54. In the year 2005, what is the difference between the % of repeaters of Euro area and % of repeaters of Bangladesh?
Provide a short and direct response. -2.73. In the year 2005, what is the difference between the % of repeaters in Euro area and % of repeaters in Kuwait?
Ensure brevity in your answer.  1.46. In the year 2005, what is the difference between the % of repeaters in Middle income and % of repeaters in Bangladesh?
Provide a succinct answer. -3.27. In the year 2005, what is the difference between the % of repeaters in Middle income and % of repeaters in Kuwait?
Make the answer very short. 0.91. In the year 2005, what is the difference between the % of repeaters in Bangladesh and % of repeaters in Kuwait?
Your answer should be compact. 4.19. In the year 2006, what is the difference between the % of repeaters in Euro area and % of repeaters in Middle income?
Offer a terse response. 0.55. In the year 2006, what is the difference between the % of repeaters in Euro area and % of repeaters in Bangladesh?
Keep it short and to the point. -3.38. In the year 2006, what is the difference between the % of repeaters in Euro area and % of repeaters in Kuwait?
Provide a short and direct response. 0.71. In the year 2006, what is the difference between the % of repeaters of Middle income and % of repeaters of Bangladesh?
Make the answer very short. -3.94. In the year 2006, what is the difference between the % of repeaters of Middle income and % of repeaters of Kuwait?
Provide a short and direct response. 0.15. In the year 2006, what is the difference between the % of repeaters in Bangladesh and % of repeaters in Kuwait?
Ensure brevity in your answer.  4.09. In the year 2007, what is the difference between the % of repeaters in Euro area and % of repeaters in Middle income?
Your response must be concise. 0.65. In the year 2007, what is the difference between the % of repeaters in Euro area and % of repeaters in Bangladesh?
Your answer should be compact. -3.46. In the year 2007, what is the difference between the % of repeaters of Euro area and % of repeaters of Kuwait?
Provide a short and direct response. 0.19. In the year 2007, what is the difference between the % of repeaters in Middle income and % of repeaters in Bangladesh?
Your response must be concise. -4.11. In the year 2007, what is the difference between the % of repeaters of Middle income and % of repeaters of Kuwait?
Provide a short and direct response. -0.46. In the year 2007, what is the difference between the % of repeaters of Bangladesh and % of repeaters of Kuwait?
Offer a very short reply. 3.65. What is the ratio of the % of repeaters of Euro area in 2000 to that in 2001?
Make the answer very short. 1.02. What is the ratio of the % of repeaters in Middle income in 2000 to that in 2001?
Your response must be concise. 1.02. What is the ratio of the % of repeaters in Bangladesh in 2000 to that in 2001?
Your response must be concise. 1.04. What is the ratio of the % of repeaters in Kuwait in 2000 to that in 2001?
Provide a succinct answer. 0.78. What is the ratio of the % of repeaters in Euro area in 2000 to that in 2002?
Keep it short and to the point. 1.05. What is the ratio of the % of repeaters of Middle income in 2000 to that in 2002?
Your answer should be compact. 1.07. What is the ratio of the % of repeaters in Bangladesh in 2000 to that in 2002?
Provide a succinct answer. 1.01. What is the ratio of the % of repeaters in Kuwait in 2000 to that in 2002?
Offer a very short reply. 0.69. What is the ratio of the % of repeaters of Euro area in 2000 to that in 2003?
Your answer should be very brief. 1.08. What is the ratio of the % of repeaters of Middle income in 2000 to that in 2003?
Offer a very short reply. 1.09. What is the ratio of the % of repeaters in Bangladesh in 2000 to that in 2003?
Offer a terse response. 0.97. What is the ratio of the % of repeaters of Euro area in 2000 to that in 2004?
Offer a very short reply. 1.05. What is the ratio of the % of repeaters of Middle income in 2000 to that in 2004?
Provide a short and direct response. 1.04. What is the ratio of the % of repeaters in Bangladesh in 2000 to that in 2004?
Your answer should be very brief. 0.63. What is the ratio of the % of repeaters of Kuwait in 2000 to that in 2004?
Provide a short and direct response. 1.1. What is the ratio of the % of repeaters in Euro area in 2000 to that in 2005?
Keep it short and to the point. 1.07. What is the ratio of the % of repeaters in Middle income in 2000 to that in 2005?
Your answer should be very brief. 1.06. What is the ratio of the % of repeaters in Bangladesh in 2000 to that in 2005?
Ensure brevity in your answer.  0.67. What is the ratio of the % of repeaters in Kuwait in 2000 to that in 2005?
Ensure brevity in your answer.  1.83. What is the ratio of the % of repeaters in Euro area in 2000 to that in 2006?
Offer a very short reply. 1.09. What is the ratio of the % of repeaters of Middle income in 2000 to that in 2006?
Make the answer very short. 1.08. What is the ratio of the % of repeaters of Bangladesh in 2000 to that in 2006?
Provide a succinct answer. 0.62. What is the ratio of the % of repeaters of Kuwait in 2000 to that in 2006?
Make the answer very short. 1.54. What is the ratio of the % of repeaters of Euro area in 2000 to that in 2007?
Provide a succinct answer. 1.1. What is the ratio of the % of repeaters of Middle income in 2000 to that in 2007?
Give a very brief answer. 1.11. What is the ratio of the % of repeaters of Bangladesh in 2000 to that in 2007?
Your answer should be compact. 0.62. What is the ratio of the % of repeaters in Kuwait in 2000 to that in 2007?
Your answer should be very brief. 1.37. What is the ratio of the % of repeaters of Euro area in 2001 to that in 2002?
Ensure brevity in your answer.  1.03. What is the ratio of the % of repeaters of Middle income in 2001 to that in 2002?
Offer a very short reply. 1.05. What is the ratio of the % of repeaters in Bangladesh in 2001 to that in 2002?
Your response must be concise. 0.97. What is the ratio of the % of repeaters of Kuwait in 2001 to that in 2002?
Your answer should be very brief. 0.89. What is the ratio of the % of repeaters in Euro area in 2001 to that in 2003?
Your answer should be compact. 1.06. What is the ratio of the % of repeaters in Middle income in 2001 to that in 2003?
Offer a terse response. 1.07. What is the ratio of the % of repeaters of Bangladesh in 2001 to that in 2003?
Offer a very short reply. 0.93. What is the ratio of the % of repeaters in Kuwait in 2001 to that in 2003?
Make the answer very short. 1.27. What is the ratio of the % of repeaters in Euro area in 2001 to that in 2004?
Offer a terse response. 1.03. What is the ratio of the % of repeaters of Middle income in 2001 to that in 2004?
Make the answer very short. 1.02. What is the ratio of the % of repeaters of Bangladesh in 2001 to that in 2004?
Offer a terse response. 0.61. What is the ratio of the % of repeaters of Kuwait in 2001 to that in 2004?
Your answer should be very brief. 1.4. What is the ratio of the % of repeaters in Euro area in 2001 to that in 2005?
Provide a succinct answer. 1.05. What is the ratio of the % of repeaters of Middle income in 2001 to that in 2005?
Your answer should be very brief. 1.04. What is the ratio of the % of repeaters in Bangladesh in 2001 to that in 2005?
Your answer should be compact. 0.64. What is the ratio of the % of repeaters of Kuwait in 2001 to that in 2005?
Your answer should be compact. 2.34. What is the ratio of the % of repeaters in Euro area in 2001 to that in 2006?
Provide a short and direct response. 1.07. What is the ratio of the % of repeaters in Middle income in 2001 to that in 2006?
Offer a terse response. 1.06. What is the ratio of the % of repeaters in Bangladesh in 2001 to that in 2006?
Provide a succinct answer. 0.6. What is the ratio of the % of repeaters in Kuwait in 2001 to that in 2006?
Your answer should be very brief. 1.96. What is the ratio of the % of repeaters in Euro area in 2001 to that in 2007?
Offer a terse response. 1.07. What is the ratio of the % of repeaters of Middle income in 2001 to that in 2007?
Offer a terse response. 1.09. What is the ratio of the % of repeaters in Bangladesh in 2001 to that in 2007?
Your answer should be very brief. 0.59. What is the ratio of the % of repeaters in Kuwait in 2001 to that in 2007?
Keep it short and to the point. 1.75. What is the ratio of the % of repeaters of Euro area in 2002 to that in 2003?
Your response must be concise. 1.03. What is the ratio of the % of repeaters of Middle income in 2002 to that in 2003?
Keep it short and to the point. 1.02. What is the ratio of the % of repeaters of Bangladesh in 2002 to that in 2003?
Make the answer very short. 0.96. What is the ratio of the % of repeaters of Kuwait in 2002 to that in 2003?
Your answer should be compact. 1.43. What is the ratio of the % of repeaters in Middle income in 2002 to that in 2004?
Keep it short and to the point. 0.97. What is the ratio of the % of repeaters of Bangladesh in 2002 to that in 2004?
Your answer should be compact. 0.63. What is the ratio of the % of repeaters of Kuwait in 2002 to that in 2004?
Offer a terse response. 1.58. What is the ratio of the % of repeaters of Euro area in 2002 to that in 2005?
Your answer should be very brief. 1.02. What is the ratio of the % of repeaters in Bangladesh in 2002 to that in 2005?
Your answer should be compact. 0.66. What is the ratio of the % of repeaters in Kuwait in 2002 to that in 2005?
Provide a short and direct response. 2.64. What is the ratio of the % of repeaters in Euro area in 2002 to that in 2006?
Give a very brief answer. 1.04. What is the ratio of the % of repeaters of Middle income in 2002 to that in 2006?
Offer a terse response. 1.01. What is the ratio of the % of repeaters in Bangladesh in 2002 to that in 2006?
Offer a terse response. 0.61. What is the ratio of the % of repeaters of Kuwait in 2002 to that in 2006?
Give a very brief answer. 2.21. What is the ratio of the % of repeaters in Euro area in 2002 to that in 2007?
Provide a short and direct response. 1.04. What is the ratio of the % of repeaters of Middle income in 2002 to that in 2007?
Offer a terse response. 1.04. What is the ratio of the % of repeaters of Bangladesh in 2002 to that in 2007?
Give a very brief answer. 0.61. What is the ratio of the % of repeaters in Kuwait in 2002 to that in 2007?
Offer a very short reply. 1.98. What is the ratio of the % of repeaters of Middle income in 2003 to that in 2004?
Offer a very short reply. 0.95. What is the ratio of the % of repeaters of Bangladesh in 2003 to that in 2004?
Make the answer very short. 0.65. What is the ratio of the % of repeaters of Kuwait in 2003 to that in 2004?
Keep it short and to the point. 1.11. What is the ratio of the % of repeaters in Middle income in 2003 to that in 2005?
Offer a very short reply. 0.97. What is the ratio of the % of repeaters in Bangladesh in 2003 to that in 2005?
Offer a very short reply. 0.69. What is the ratio of the % of repeaters of Kuwait in 2003 to that in 2005?
Keep it short and to the point. 1.85. What is the ratio of the % of repeaters in Euro area in 2003 to that in 2006?
Your response must be concise. 1.01. What is the ratio of the % of repeaters of Bangladesh in 2003 to that in 2006?
Your response must be concise. 0.64. What is the ratio of the % of repeaters in Kuwait in 2003 to that in 2006?
Your response must be concise. 1.55. What is the ratio of the % of repeaters in Euro area in 2003 to that in 2007?
Ensure brevity in your answer.  1.02. What is the ratio of the % of repeaters of Middle income in 2003 to that in 2007?
Provide a short and direct response. 1.02. What is the ratio of the % of repeaters of Bangladesh in 2003 to that in 2007?
Offer a terse response. 0.63. What is the ratio of the % of repeaters of Kuwait in 2003 to that in 2007?
Make the answer very short. 1.38. What is the ratio of the % of repeaters of Euro area in 2004 to that in 2005?
Offer a terse response. 1.02. What is the ratio of the % of repeaters in Middle income in 2004 to that in 2005?
Make the answer very short. 1.02. What is the ratio of the % of repeaters of Bangladesh in 2004 to that in 2005?
Your response must be concise. 1.05. What is the ratio of the % of repeaters of Kuwait in 2004 to that in 2005?
Your answer should be very brief. 1.67. What is the ratio of the % of repeaters in Euro area in 2004 to that in 2006?
Provide a short and direct response. 1.04. What is the ratio of the % of repeaters in Middle income in 2004 to that in 2006?
Offer a terse response. 1.04. What is the ratio of the % of repeaters in Bangladesh in 2004 to that in 2006?
Your answer should be very brief. 0.98. What is the ratio of the % of repeaters in Kuwait in 2004 to that in 2006?
Your answer should be very brief. 1.4. What is the ratio of the % of repeaters of Euro area in 2004 to that in 2007?
Offer a terse response. 1.04. What is the ratio of the % of repeaters of Middle income in 2004 to that in 2007?
Ensure brevity in your answer.  1.07. What is the ratio of the % of repeaters of Bangladesh in 2004 to that in 2007?
Keep it short and to the point. 0.97. What is the ratio of the % of repeaters of Kuwait in 2004 to that in 2007?
Your response must be concise. 1.25. What is the ratio of the % of repeaters of Euro area in 2005 to that in 2006?
Provide a short and direct response. 1.02. What is the ratio of the % of repeaters in Middle income in 2005 to that in 2006?
Give a very brief answer. 1.02. What is the ratio of the % of repeaters of Bangladesh in 2005 to that in 2006?
Keep it short and to the point. 0.93. What is the ratio of the % of repeaters of Kuwait in 2005 to that in 2006?
Offer a terse response. 0.84. What is the ratio of the % of repeaters of Euro area in 2005 to that in 2007?
Your answer should be compact. 1.02. What is the ratio of the % of repeaters in Middle income in 2005 to that in 2007?
Keep it short and to the point. 1.05. What is the ratio of the % of repeaters in Bangladesh in 2005 to that in 2007?
Offer a very short reply. 0.92. What is the ratio of the % of repeaters in Kuwait in 2005 to that in 2007?
Keep it short and to the point. 0.75. What is the ratio of the % of repeaters of Euro area in 2006 to that in 2007?
Give a very brief answer. 1. What is the ratio of the % of repeaters in Middle income in 2006 to that in 2007?
Provide a succinct answer. 1.03. What is the ratio of the % of repeaters in Bangladesh in 2006 to that in 2007?
Provide a short and direct response. 0.99. What is the ratio of the % of repeaters of Kuwait in 2006 to that in 2007?
Ensure brevity in your answer.  0.89. What is the difference between the highest and the second highest % of repeaters of Euro area?
Ensure brevity in your answer.  0.11. What is the difference between the highest and the second highest % of repeaters of Middle income?
Give a very brief answer. 0.09. What is the difference between the highest and the second highest % of repeaters in Bangladesh?
Offer a very short reply. 0.05. What is the difference between the highest and the second highest % of repeaters of Kuwait?
Provide a succinct answer. 1.03. What is the difference between the highest and the lowest % of repeaters of Euro area?
Your response must be concise. 0.46. What is the difference between the highest and the lowest % of repeaters of Middle income?
Offer a very short reply. 0.47. What is the difference between the highest and the lowest % of repeaters in Bangladesh?
Give a very brief answer. 3.38. What is the difference between the highest and the lowest % of repeaters in Kuwait?
Provide a succinct answer. 5.67. 